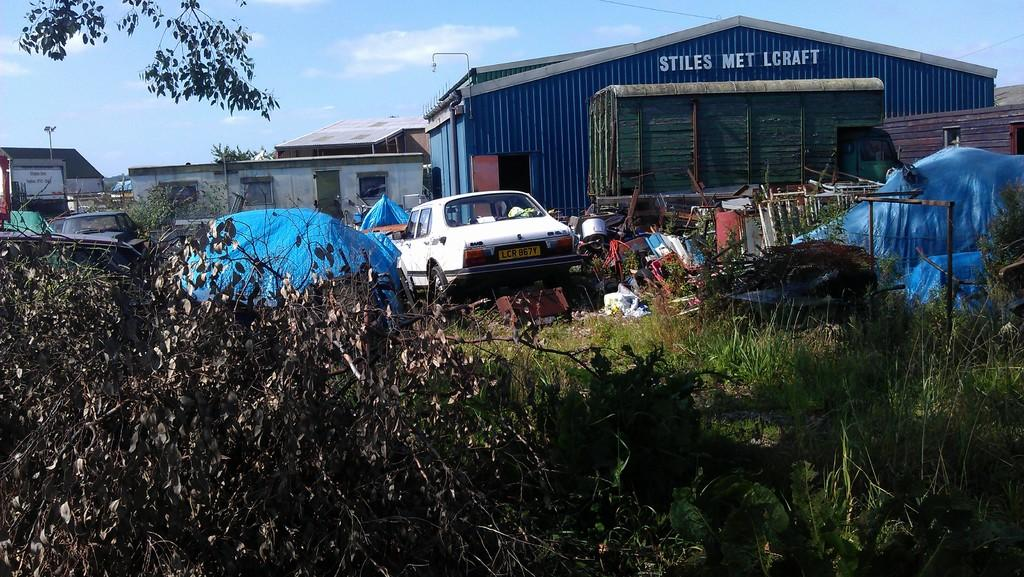What type of vegetation can be seen in the image? There are trees, plants, and grass in the image. What type of structure can be seen in the image? There is a dump, cars, a shed, and wooden houses in the image. What are the poles used for in the image? The poles in the image are likely used for supporting wires or other structures. What is visible in the background of the image? The sky is visible in the background of the image, with clouds present. How does the image show respect for the environment? The image itself does not convey respect for the environment; it is a visual representation of various objects and structures. What type of gardening tool can be seen in the image? There is no gardening tool, such as a rake, present in the image. 